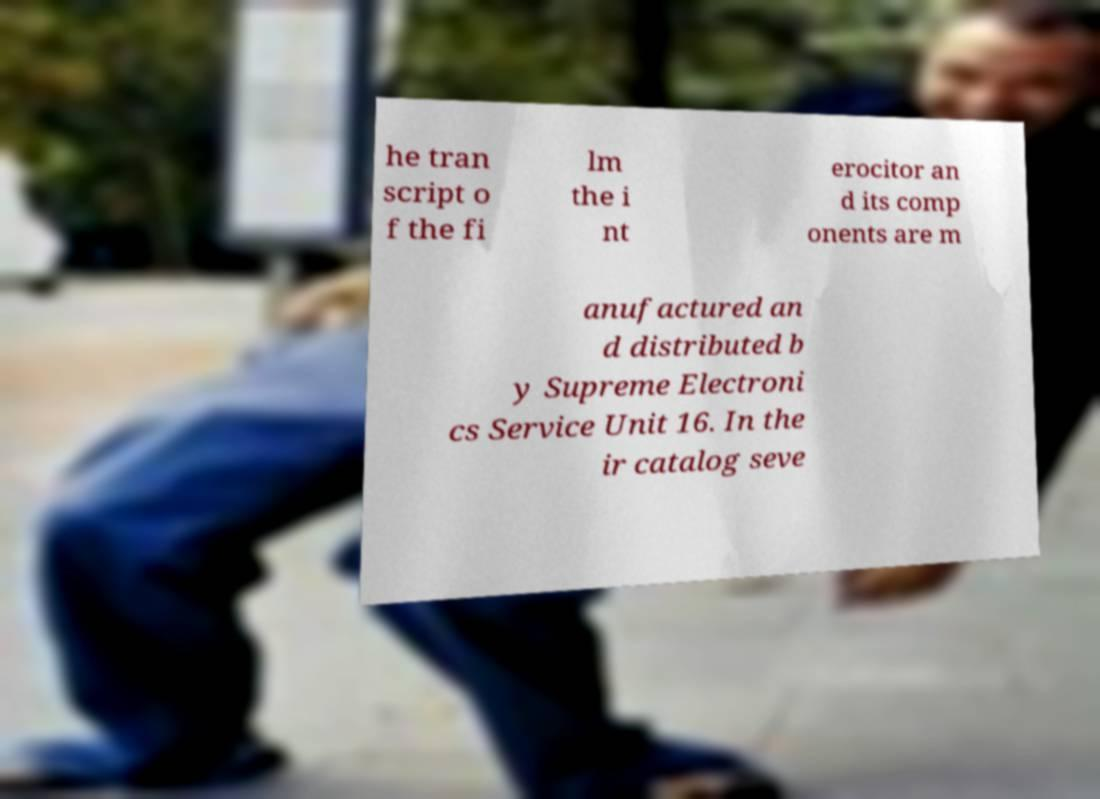There's text embedded in this image that I need extracted. Can you transcribe it verbatim? he tran script o f the fi lm the i nt erocitor an d its comp onents are m anufactured an d distributed b y Supreme Electroni cs Service Unit 16. In the ir catalog seve 